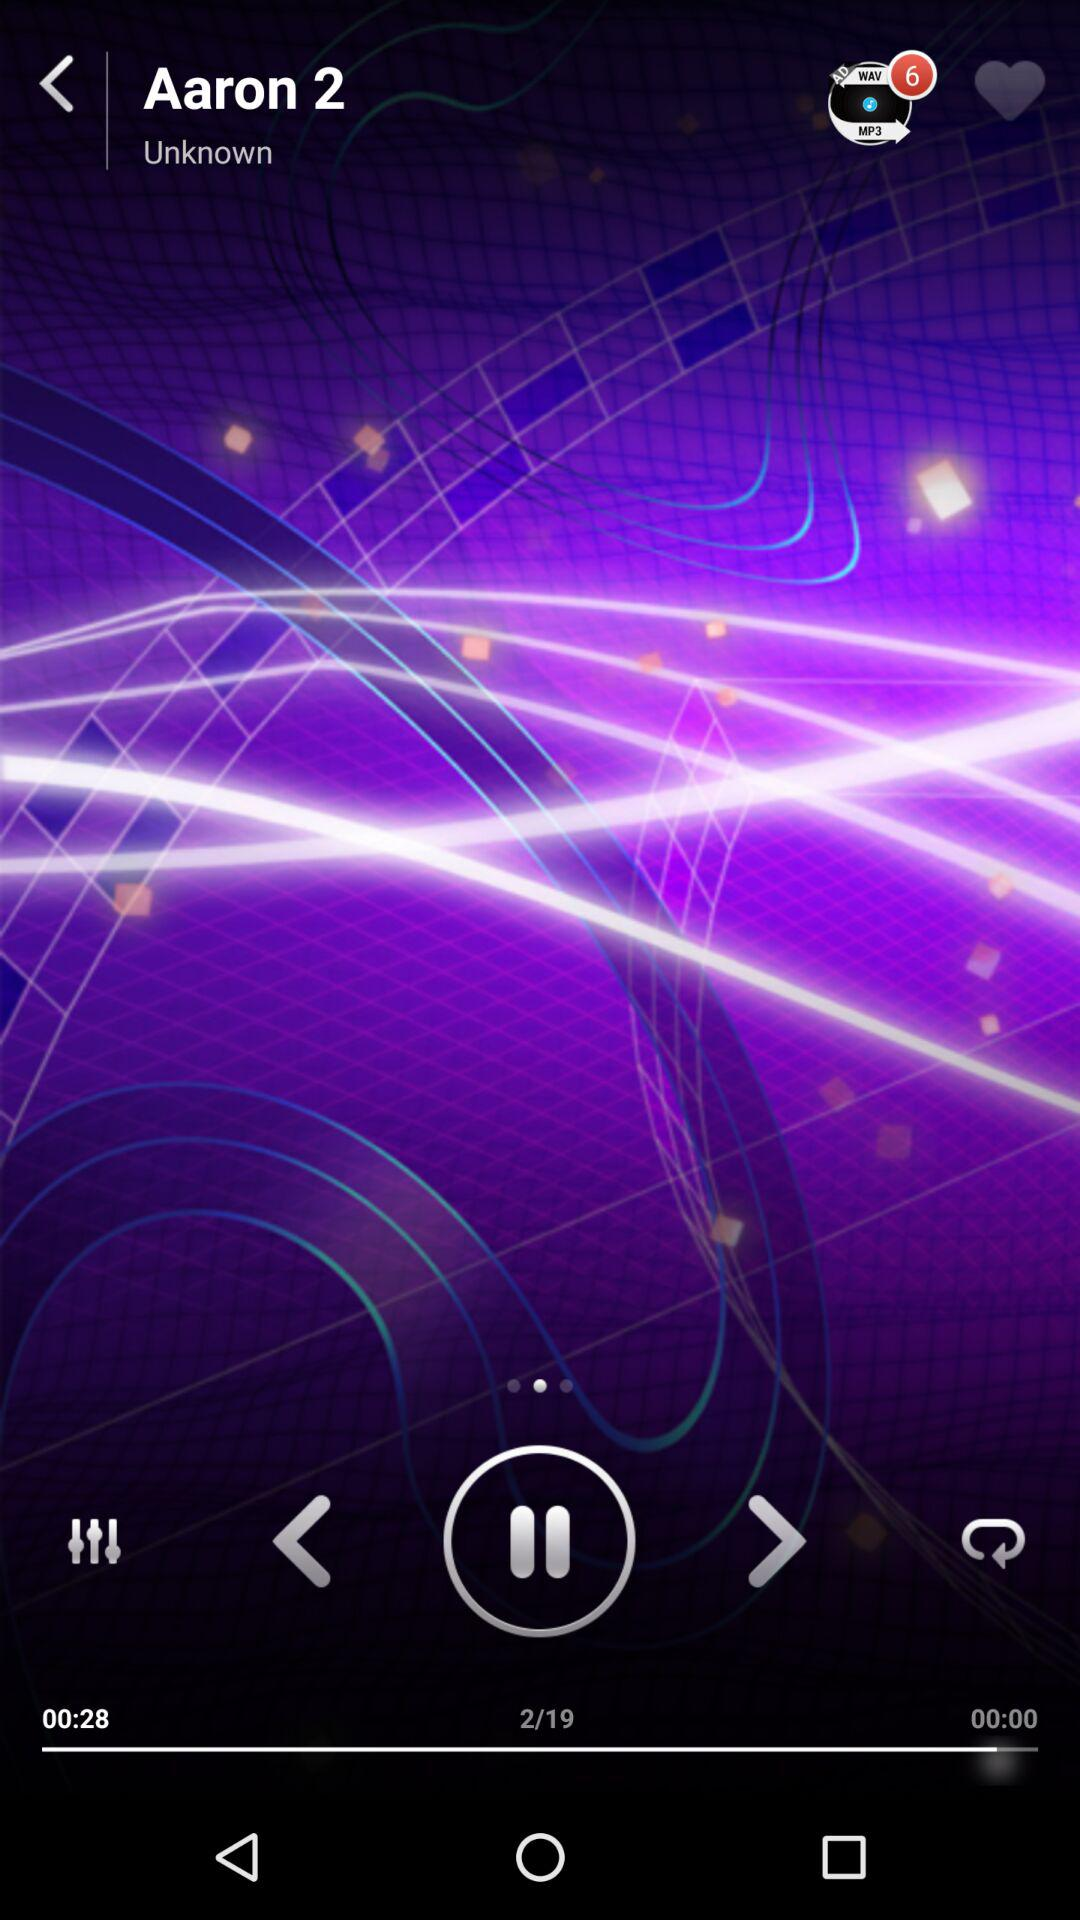What is the time duration of the song "Aaron 2"? The time duration of the song "Aaron 2" is 00:28. 